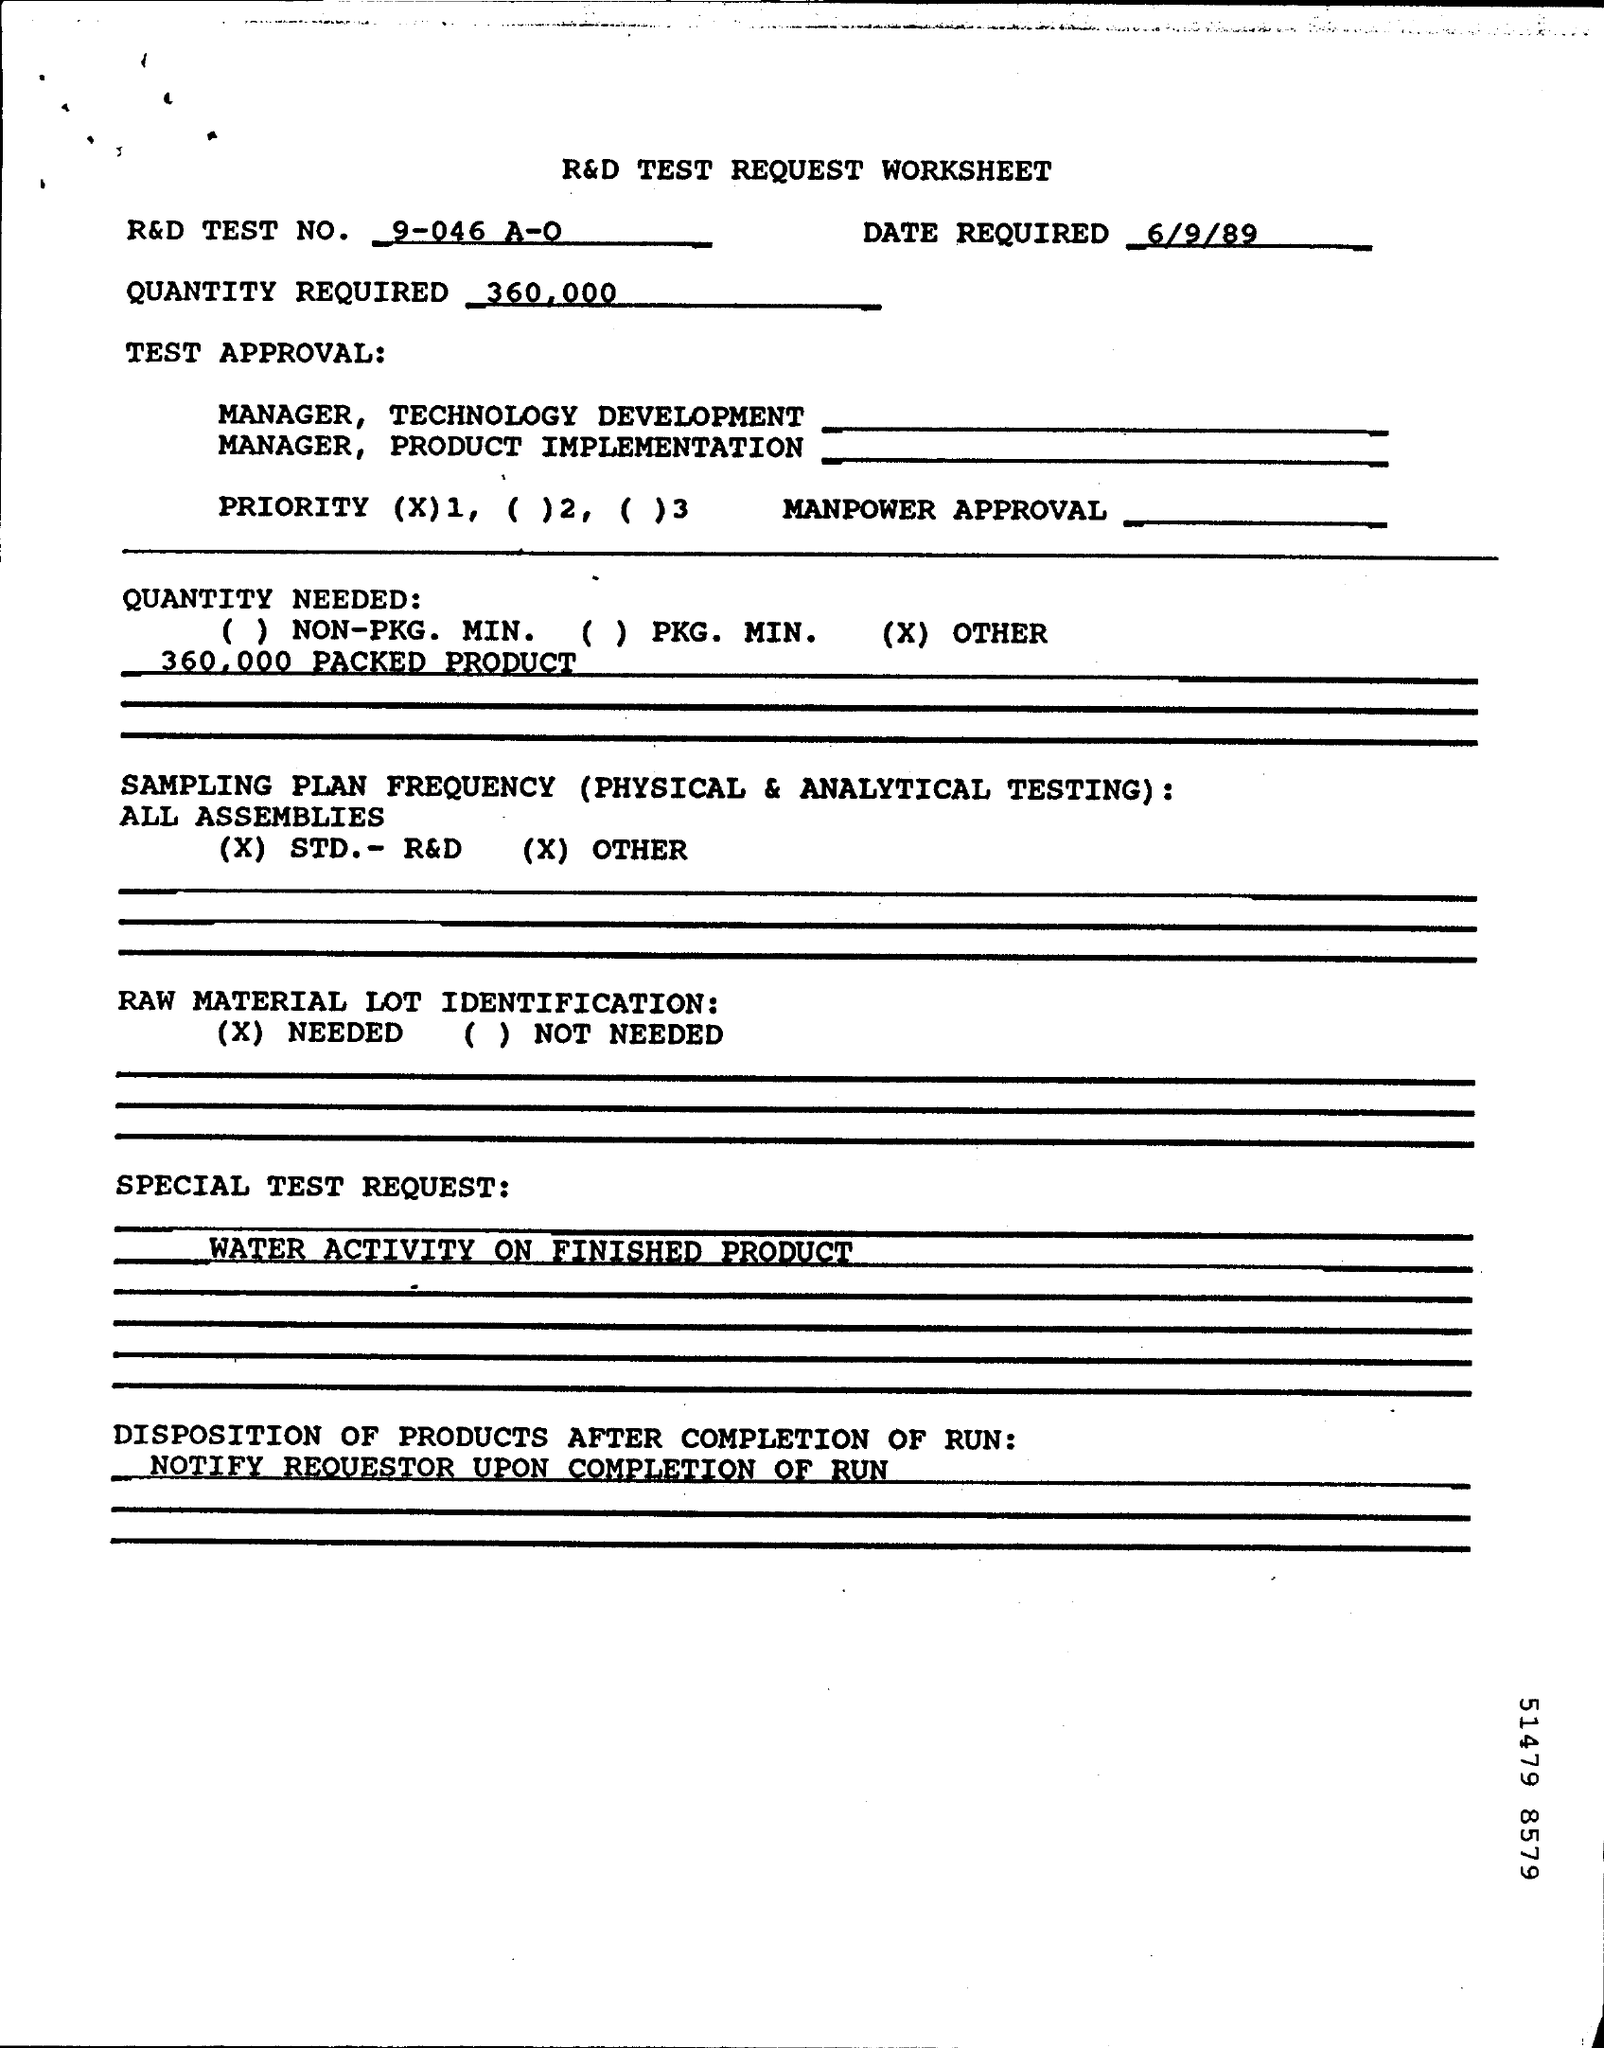When is the Memorandum dated on ?
Your answer should be compact. 6/9/89. How much Quantity Required ?
Your answer should be compact. 360,000. What is the R&D TEST NUMBER ?
Your answer should be very brief. 9-046 A-O. 